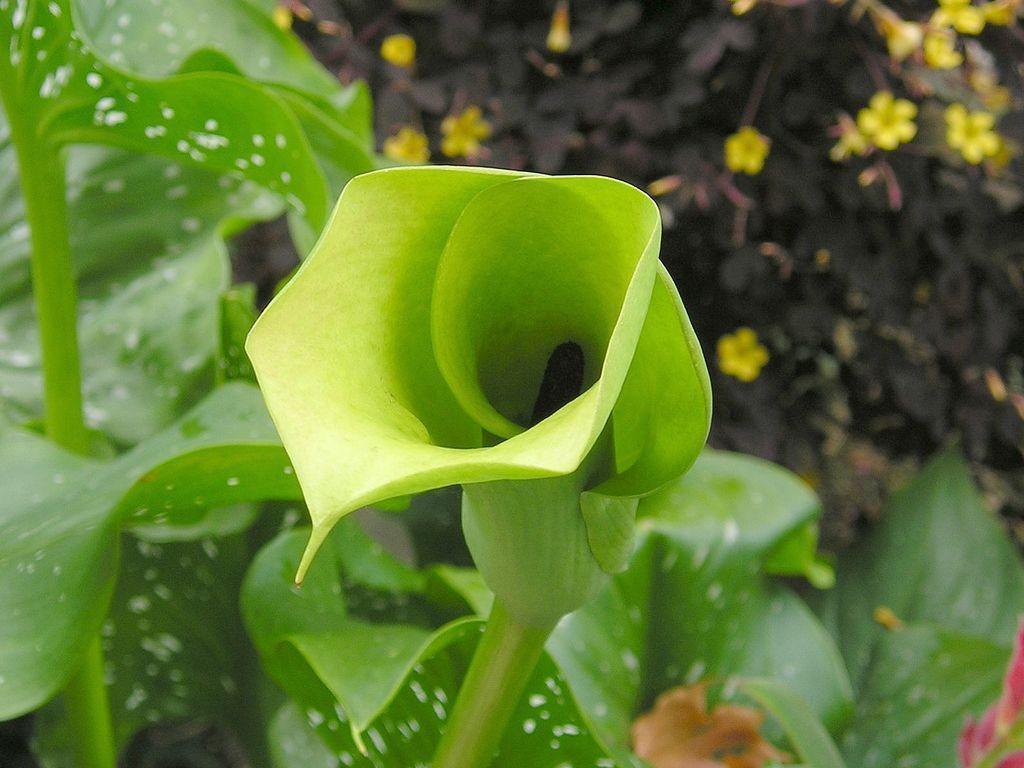Describe this image in one or two sentences. In this image I see green leaves and I see followers over here which are of yellow in color and I see the black thing, 